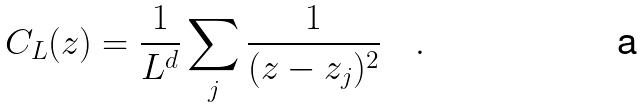<formula> <loc_0><loc_0><loc_500><loc_500>C _ { L } ( z ) = \frac { 1 } { L ^ { d } } \sum _ { j } { \frac { 1 } { ( z - z _ { j } ) ^ { 2 } } } \quad .</formula> 